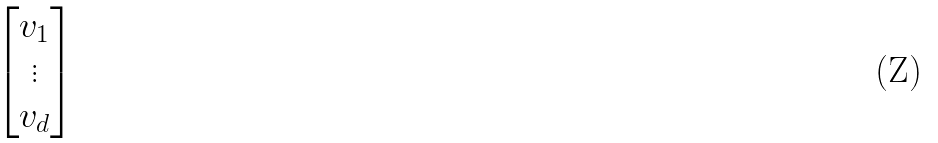Convert formula to latex. <formula><loc_0><loc_0><loc_500><loc_500>\begin{bmatrix} v _ { 1 } \\ \vdots \\ v _ { d } \end{bmatrix}</formula> 